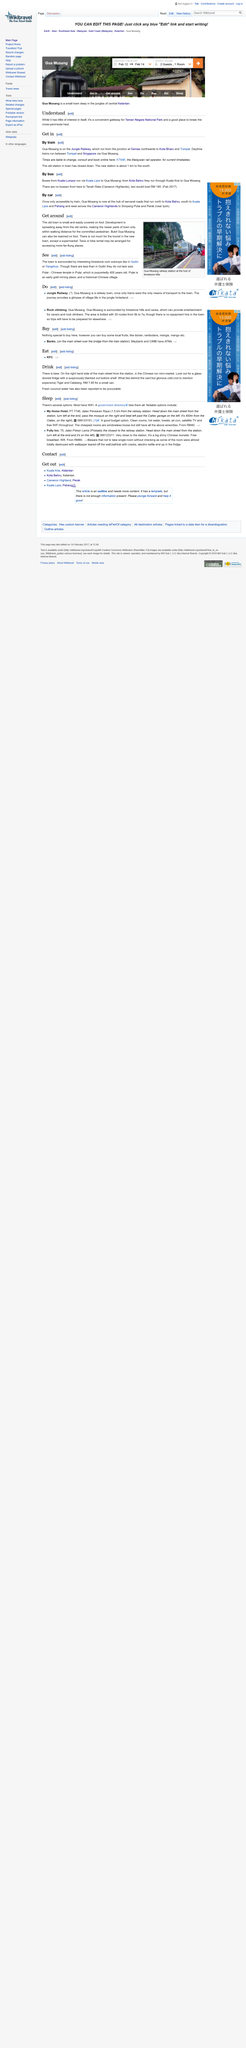Give some essential details in this illustration. The Chinese temple in Pulai is purportedly 400 years old. The photograph depicts Gua Musang railway station situated at the base of limestone hills. The new town offers limited amenities for tourists, with only a supermarket being available for their convenience. 